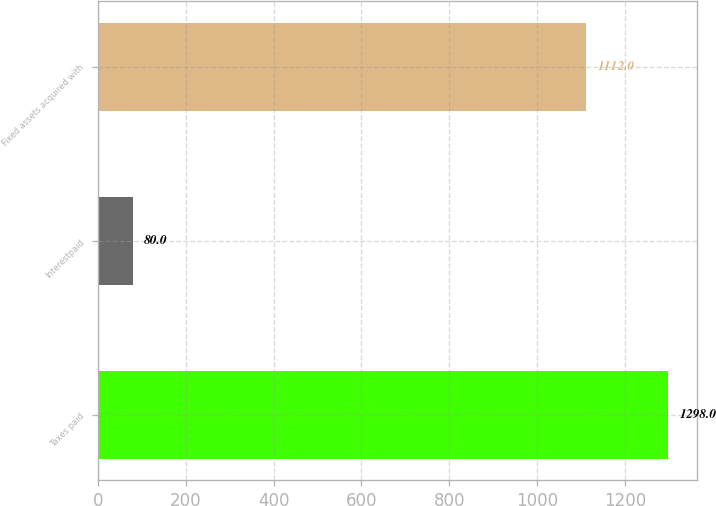<chart> <loc_0><loc_0><loc_500><loc_500><bar_chart><fcel>Taxes paid<fcel>Interestpaid<fcel>Fixed assets acquired with<nl><fcel>1298<fcel>80<fcel>1112<nl></chart> 